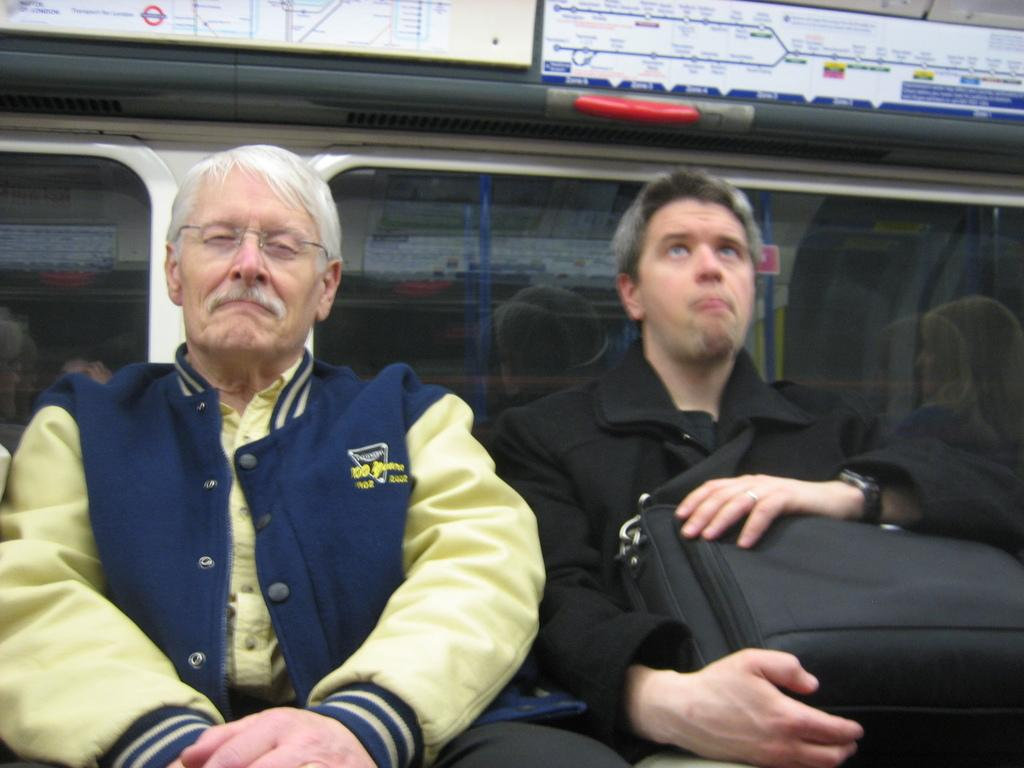How many people are in the image? There are two men in the image. What are the men doing in the image? The men are sitting beside each other. What is visible behind the men? There is a glass window behind the men. What is located at the top of the image? There is a route map at the top of the image. What is the man on the right side holding? The man on the right side is holding a bag. What time is displayed on the hourglass in the image? There is no hourglass present in the image. 